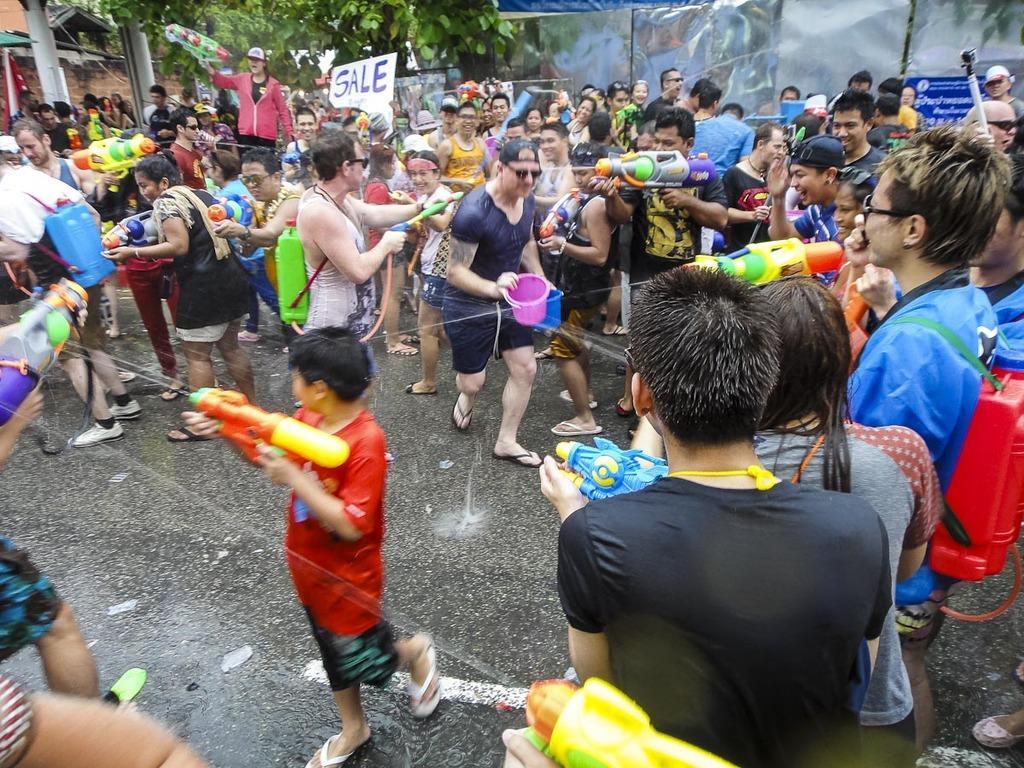Describe this image in one or two sentences. In the foreground of this image, there are people standing on the road and holding water guns, buckets and the water pipe in their hands. In the background, there are few posters, a metal sheet boundary, a tree and a wall. 